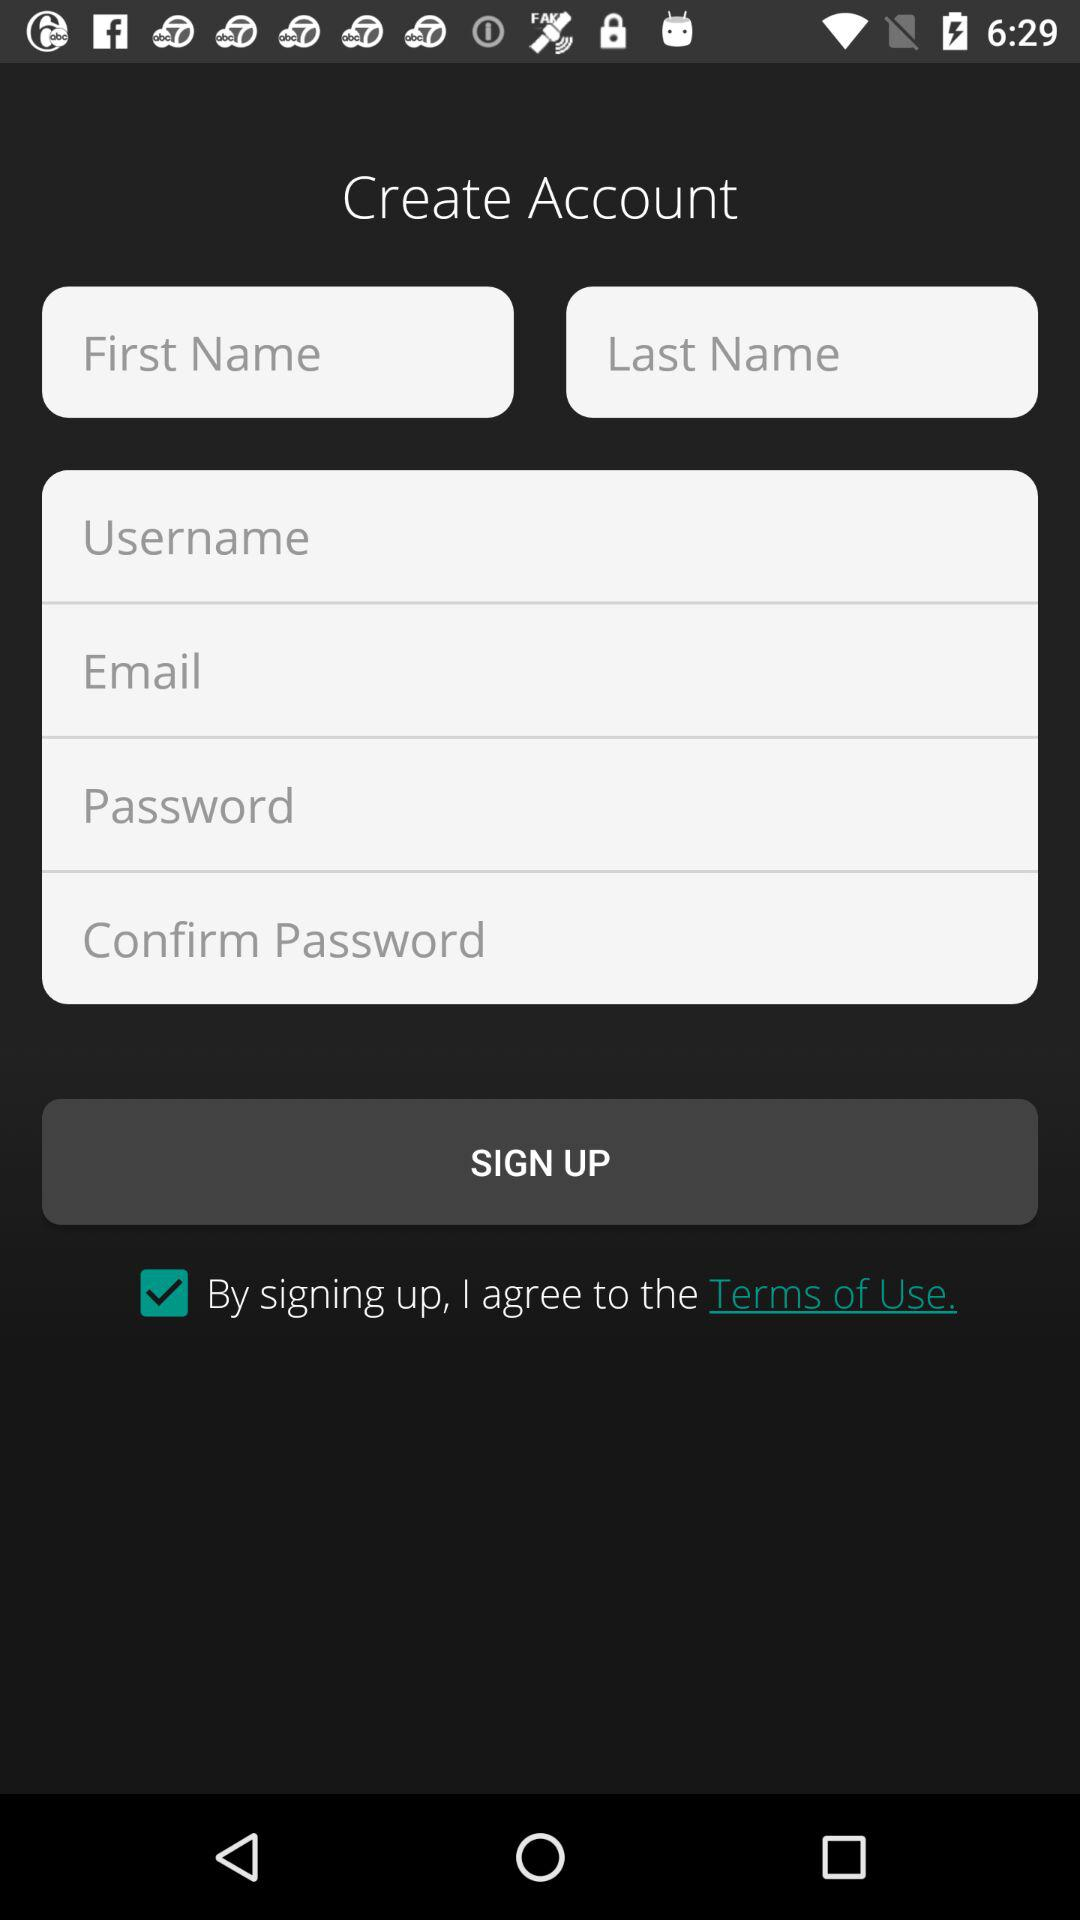How many text inputs are required to create an account?
Answer the question using a single word or phrase. 6 